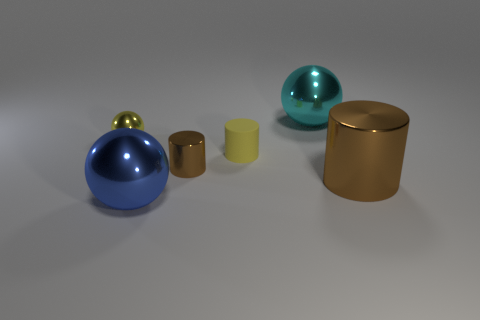What number of big spheres are on the right side of the metal ball that is in front of the yellow sphere?
Provide a succinct answer. 1. The thing that is in front of the large cyan shiny ball and to the right of the small matte cylinder has what shape?
Give a very brief answer. Cylinder. The big ball behind the brown shiny cylinder in front of the tiny metal object in front of the tiny yellow cylinder is made of what material?
Offer a terse response. Metal. The thing that is the same color as the tiny metal cylinder is what size?
Your answer should be very brief. Large. What material is the tiny brown cylinder?
Give a very brief answer. Metal. Is the material of the blue sphere the same as the brown thing in front of the tiny brown metallic cylinder?
Your response must be concise. Yes. There is a shiny cylinder to the left of the large metallic sphere that is right of the blue thing; what is its color?
Give a very brief answer. Brown. How big is the sphere that is behind the large brown cylinder and to the left of the cyan metallic thing?
Give a very brief answer. Small. There is a small brown thing; is it the same shape as the large object that is right of the large cyan metallic ball?
Your answer should be very brief. Yes. How many brown things are in front of the blue sphere?
Your answer should be very brief. 0. 